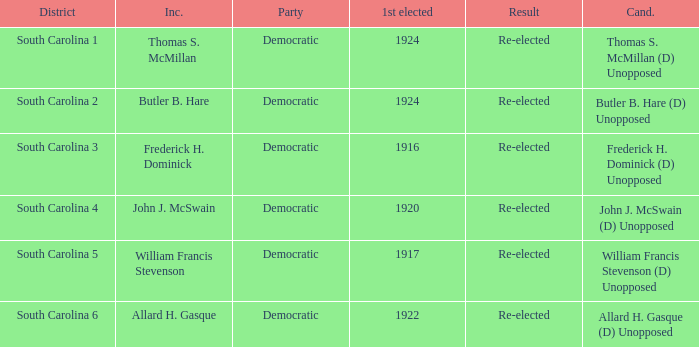What is the result for thomas s. mcmillan? Re-elected. 